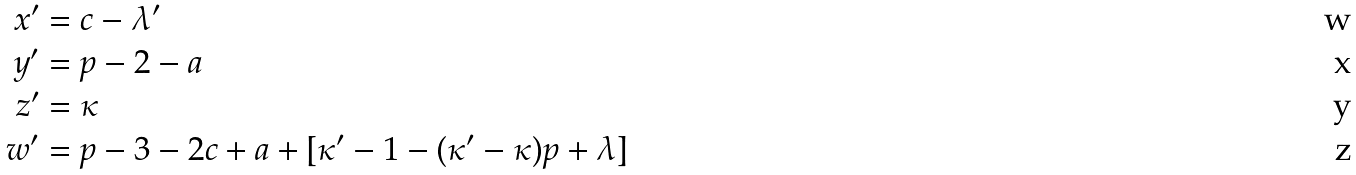<formula> <loc_0><loc_0><loc_500><loc_500>x ^ { \prime } & = c - \lambda ^ { \prime } \\ y ^ { \prime } & = p - 2 - a \\ z ^ { \prime } & = \kappa \\ w ^ { \prime } & = p - 3 - 2 c + a + [ \kappa ^ { \prime } - 1 - ( \kappa ^ { \prime } - \kappa ) p + \lambda ]</formula> 